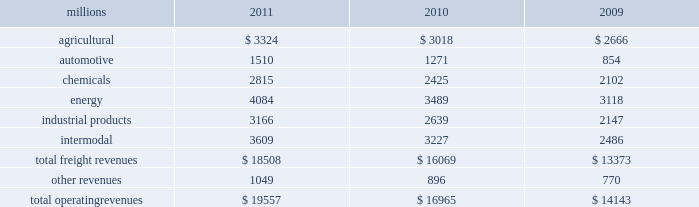Notes to the consolidated financial statements union pacific corporation and subsidiary companies for purposes of this report , unless the context otherwise requires , all references herein to the 201ccorporation 201d , 201cupc 201d , 201cwe 201d , 201cus 201d , and 201cour 201d mean union pacific corporation and its subsidiaries , including union pacific railroad company , which will be separately referred to herein as 201cuprr 201d or the 201crailroad 201d .
Nature of operations operations and segmentation 2013 we are a class i railroad that operates in the u.s .
Our network includes 31898 route miles , linking pacific coast and gulf coast ports with the midwest and eastern u.s .
Gateways and providing several corridors to key mexican gateways .
We own 26027 miles and operate on the remainder pursuant to trackage rights or leases .
We serve the western two-thirds of the country and maintain coordinated schedules with other rail carriers for the handling of freight to and from the atlantic coast , the pacific coast , the southeast , the southwest , canada , and mexico .
Export and import traffic is moved through gulf coast and pacific coast ports and across the mexican and canadian borders .
The railroad , along with its subsidiaries and rail affiliates , is our one reportable operating segment .
Although revenue is analyzed by commodity group , we analyze the net financial results of the railroad as one segment due to the integrated nature of our rail network .
The table provides freight revenue by commodity group : millions 2011 2010 2009 .
Although our revenues are principally derived from customers domiciled in the u.s. , the ultimate points of origination or destination for some products transported by us are outside the u.s .
Basis of presentation 2013 the consolidated financial statements are presented in accordance with accounting principles generally accepted in the u.s .
( gaap ) as codified in the financial accounting standards board ( fasb ) accounting standards codification ( asc ) .
Certain prior year amounts have been disaggregated to provide more detail and conform to the current period financial statement presentation .
Significant accounting policies principles of consolidation 2013 the consolidated financial statements include the accounts of union pacific corporation and all of its subsidiaries .
Investments in affiliated companies ( 20% ( 20 % ) to 50% ( 50 % ) owned ) are accounted for using the equity method of accounting .
All intercompany transactions are eliminated .
We currently have no less than majority-owned investments that require consolidation under variable interest entity requirements .
Cash and cash equivalents 2013 cash equivalents consist of investments with original maturities of three months or less .
Accounts receivable 2013 accounts receivable includes receivables reduced by an allowance for doubtful accounts .
The allowance is based upon historical losses , credit worthiness of customers , and current economic conditions .
Receivables not expected to be collected in one year and the associated allowances are classified as other assets in our consolidated statements of financial position. .
What percent of total freight revenues was automotive in 2011? 
Computations: (1510 / 18508)
Answer: 0.08159. 